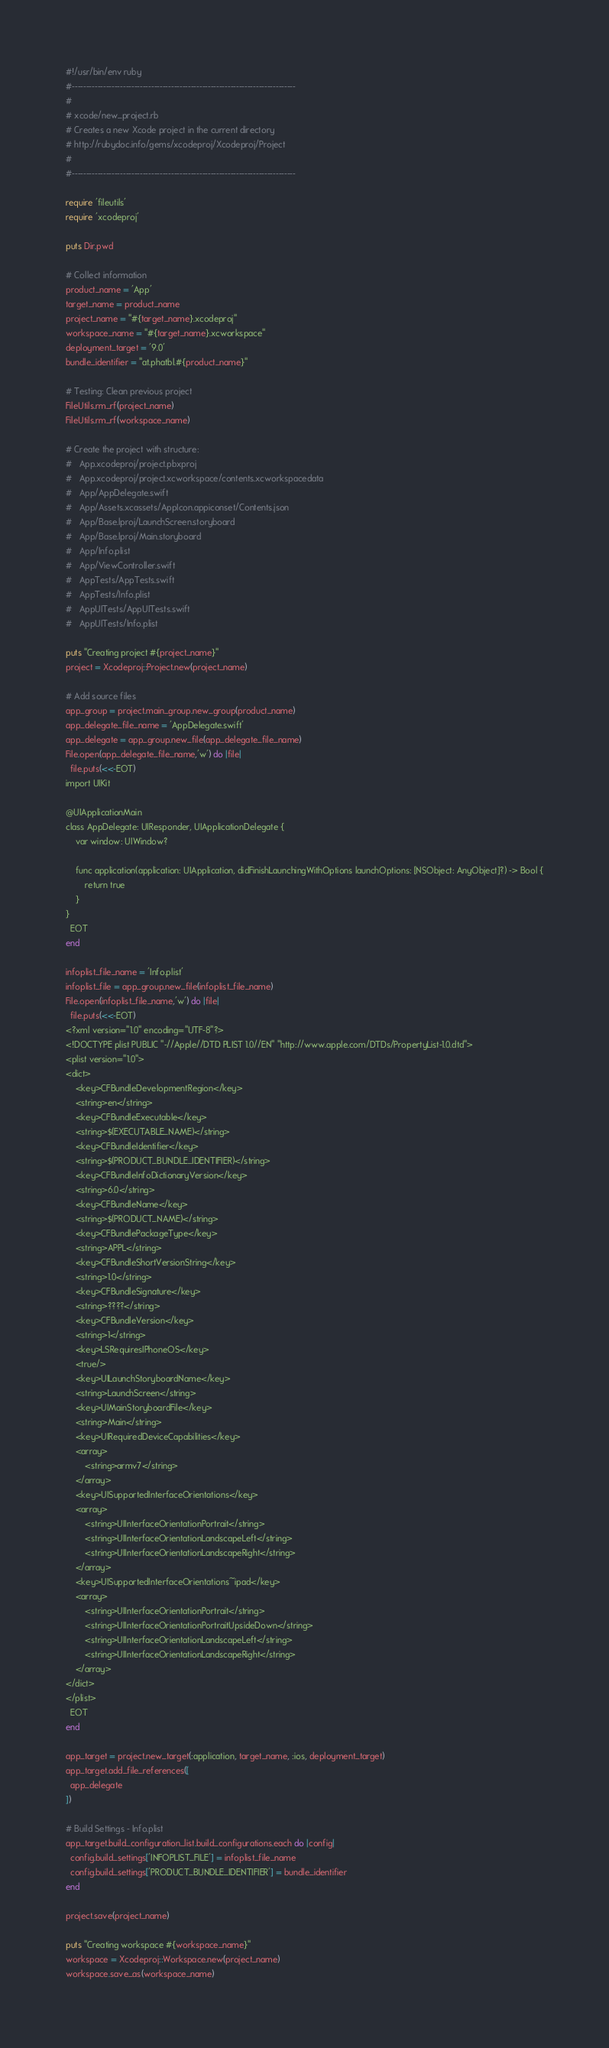Convert code to text. <code><loc_0><loc_0><loc_500><loc_500><_Ruby_>#!/usr/bin/env ruby
#-------------------------------------------------------------------------------
#
# xcode/new_project.rb
# Creates a new Xcode project in the current directory
# http://rubydoc.info/gems/xcodeproj/Xcodeproj/Project
#
#-------------------------------------------------------------------------------

require 'fileutils'
require 'xcodeproj'

puts Dir.pwd

# Collect information
product_name = 'App'
target_name = product_name
project_name = "#{target_name}.xcodeproj"
workspace_name = "#{target_name}.xcworkspace"
deployment_target = '9.0'
bundle_identifier = "at.phatbl.#{product_name}"

# Testing: Clean previous project
FileUtils.rm_rf(project_name)
FileUtils.rm_rf(workspace_name)

# Create the project with structure:
#   App.xcodeproj/project.pbxproj
#   App.xcodeproj/project.xcworkspace/contents.xcworkspacedata
#   App/AppDelegate.swift
#   App/Assets.xcassets/AppIcon.appiconset/Contents.json
#   App/Base.lproj/LaunchScreen.storyboard
#   App/Base.lproj/Main.storyboard
#   App/Info.plist
#   App/ViewController.swift
#   AppTests/AppTests.swift
#   AppTests/Info.plist
#   AppUITests/AppUITests.swift
#   AppUITests/Info.plist

puts "Creating project #{project_name}"
project = Xcodeproj::Project.new(project_name)

# Add source files
app_group = project.main_group.new_group(product_name)
app_delegate_file_name = 'AppDelegate.swift'
app_delegate = app_group.new_file(app_delegate_file_name)
File.open(app_delegate_file_name,'w') do |file|
  file.puts(<<-EOT)
import UIKit

@UIApplicationMain
class AppDelegate: UIResponder, UIApplicationDelegate {
    var window: UIWindow?

    func application(application: UIApplication, didFinishLaunchingWithOptions launchOptions: [NSObject: AnyObject]?) -> Bool {
        return true
    }
}
  EOT
end

infoplist_file_name = 'Info.plist'
infoplist_file = app_group.new_file(infoplist_file_name)
File.open(infoplist_file_name,'w') do |file|
  file.puts(<<-EOT)
<?xml version="1.0" encoding="UTF-8"?>
<!DOCTYPE plist PUBLIC "-//Apple//DTD PLIST 1.0//EN" "http://www.apple.com/DTDs/PropertyList-1.0.dtd">
<plist version="1.0">
<dict>
	<key>CFBundleDevelopmentRegion</key>
	<string>en</string>
	<key>CFBundleExecutable</key>
	<string>$(EXECUTABLE_NAME)</string>
	<key>CFBundleIdentifier</key>
	<string>$(PRODUCT_BUNDLE_IDENTIFIER)</string>
	<key>CFBundleInfoDictionaryVersion</key>
	<string>6.0</string>
	<key>CFBundleName</key>
	<string>$(PRODUCT_NAME)</string>
	<key>CFBundlePackageType</key>
	<string>APPL</string>
	<key>CFBundleShortVersionString</key>
	<string>1.0</string>
	<key>CFBundleSignature</key>
	<string>????</string>
	<key>CFBundleVersion</key>
	<string>1</string>
	<key>LSRequiresIPhoneOS</key>
	<true/>
	<key>UILaunchStoryboardName</key>
	<string>LaunchScreen</string>
	<key>UIMainStoryboardFile</key>
	<string>Main</string>
	<key>UIRequiredDeviceCapabilities</key>
	<array>
		<string>armv7</string>
	</array>
	<key>UISupportedInterfaceOrientations</key>
	<array>
		<string>UIInterfaceOrientationPortrait</string>
		<string>UIInterfaceOrientationLandscapeLeft</string>
		<string>UIInterfaceOrientationLandscapeRight</string>
	</array>
	<key>UISupportedInterfaceOrientations~ipad</key>
	<array>
		<string>UIInterfaceOrientationPortrait</string>
		<string>UIInterfaceOrientationPortraitUpsideDown</string>
		<string>UIInterfaceOrientationLandscapeLeft</string>
		<string>UIInterfaceOrientationLandscapeRight</string>
	</array>
</dict>
</plist>
  EOT
end

app_target = project.new_target(:application, target_name, :ios, deployment_target)
app_target.add_file_references([
  app_delegate
])

# Build Settings - Info.plist
app_target.build_configuration_list.build_configurations.each do |config|
  config.build_settings['INFOPLIST_FILE'] = infoplist_file_name
  config.build_settings['PRODUCT_BUNDLE_IDENTIFIER'] = bundle_identifier
end

project.save(project_name)

puts "Creating workspace #{workspace_name}"
workspace = Xcodeproj::Workspace.new(project_name)
workspace.save_as(workspace_name)
</code> 